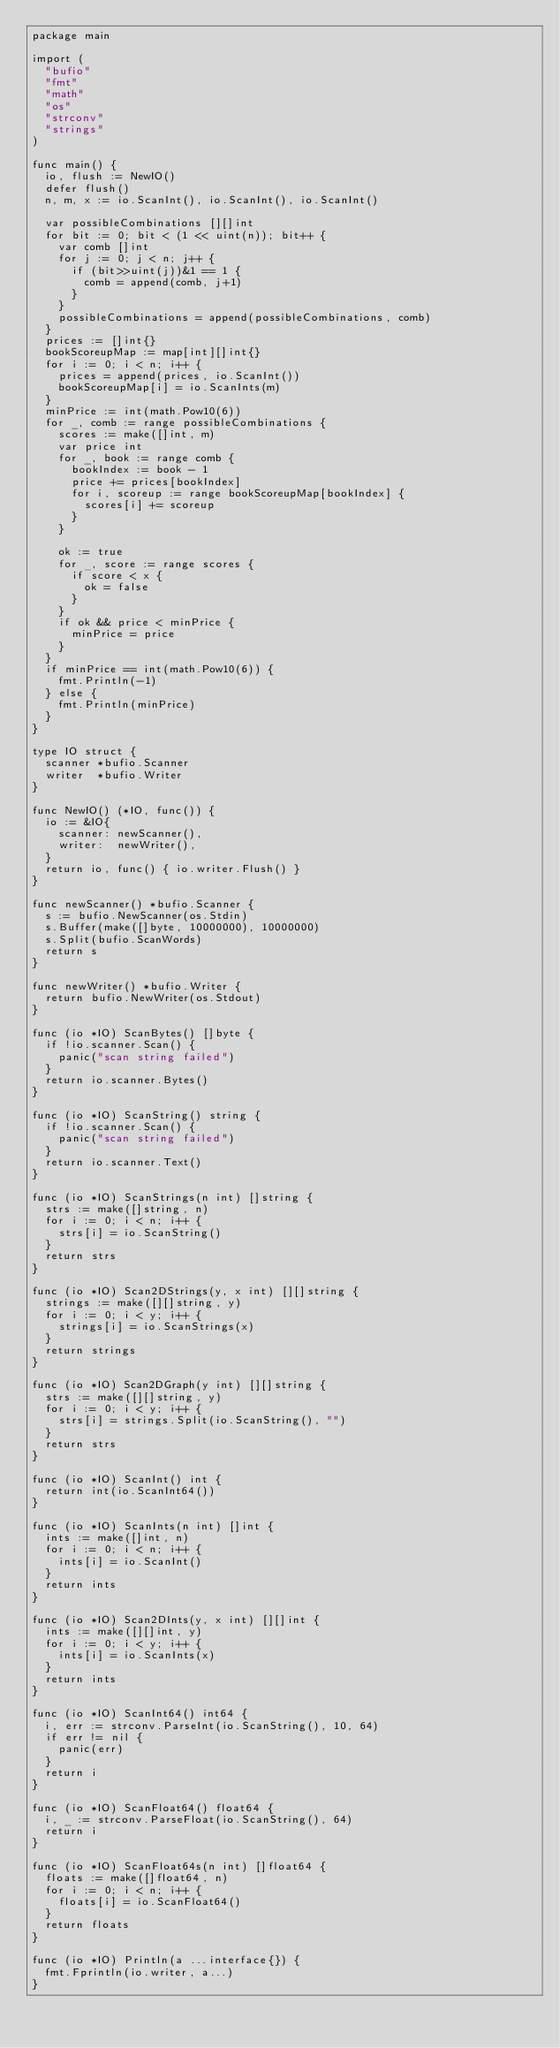<code> <loc_0><loc_0><loc_500><loc_500><_Go_>package main

import (
	"bufio"
	"fmt"
	"math"
	"os"
	"strconv"
	"strings"
)

func main() {
	io, flush := NewIO()
	defer flush()
	n, m, x := io.ScanInt(), io.ScanInt(), io.ScanInt()

	var possibleCombinations [][]int
	for bit := 0; bit < (1 << uint(n)); bit++ {
		var comb []int
		for j := 0; j < n; j++ {
			if (bit>>uint(j))&1 == 1 {
				comb = append(comb, j+1)
			}
		}
		possibleCombinations = append(possibleCombinations, comb)
	}
	prices := []int{}
	bookScoreupMap := map[int][]int{}
	for i := 0; i < n; i++ {
		prices = append(prices, io.ScanInt())
		bookScoreupMap[i] = io.ScanInts(m)
	}
	minPrice := int(math.Pow10(6))
	for _, comb := range possibleCombinations {
		scores := make([]int, m)
		var price int
		for _, book := range comb {
			bookIndex := book - 1
			price += prices[bookIndex]
			for i, scoreup := range bookScoreupMap[bookIndex] {
				scores[i] += scoreup
			}
		}

		ok := true
		for _, score := range scores {
			if score < x {
				ok = false
			}
		}
		if ok && price < minPrice {
			minPrice = price
		}
	}
	if minPrice == int(math.Pow10(6)) {
		fmt.Println(-1)
	} else {
		fmt.Println(minPrice)
	}
}

type IO struct {
	scanner *bufio.Scanner
	writer  *bufio.Writer
}

func NewIO() (*IO, func()) {
	io := &IO{
		scanner: newScanner(),
		writer:  newWriter(),
	}
	return io, func() { io.writer.Flush() }
}

func newScanner() *bufio.Scanner {
	s := bufio.NewScanner(os.Stdin)
	s.Buffer(make([]byte, 10000000), 10000000)
	s.Split(bufio.ScanWords)
	return s
}

func newWriter() *bufio.Writer {
	return bufio.NewWriter(os.Stdout)
}

func (io *IO) ScanBytes() []byte {
	if !io.scanner.Scan() {
		panic("scan string failed")
	}
	return io.scanner.Bytes()
}

func (io *IO) ScanString() string {
	if !io.scanner.Scan() {
		panic("scan string failed")
	}
	return io.scanner.Text()
}

func (io *IO) ScanStrings(n int) []string {
	strs := make([]string, n)
	for i := 0; i < n; i++ {
		strs[i] = io.ScanString()
	}
	return strs
}

func (io *IO) Scan2DStrings(y, x int) [][]string {
	strings := make([][]string, y)
	for i := 0; i < y; i++ {
		strings[i] = io.ScanStrings(x)
	}
	return strings
}

func (io *IO) Scan2DGraph(y int) [][]string {
	strs := make([][]string, y)
	for i := 0; i < y; i++ {
		strs[i] = strings.Split(io.ScanString(), "")
	}
	return strs
}

func (io *IO) ScanInt() int {
	return int(io.ScanInt64())
}

func (io *IO) ScanInts(n int) []int {
	ints := make([]int, n)
	for i := 0; i < n; i++ {
		ints[i] = io.ScanInt()
	}
	return ints
}

func (io *IO) Scan2DInts(y, x int) [][]int {
	ints := make([][]int, y)
	for i := 0; i < y; i++ {
		ints[i] = io.ScanInts(x)
	}
	return ints
}

func (io *IO) ScanInt64() int64 {
	i, err := strconv.ParseInt(io.ScanString(), 10, 64)
	if err != nil {
		panic(err)
	}
	return i
}

func (io *IO) ScanFloat64() float64 {
	i, _ := strconv.ParseFloat(io.ScanString(), 64)
	return i
}

func (io *IO) ScanFloat64s(n int) []float64 {
	floats := make([]float64, n)
	for i := 0; i < n; i++ {
		floats[i] = io.ScanFloat64()
	}
	return floats
}

func (io *IO) Println(a ...interface{}) {
	fmt.Fprintln(io.writer, a...)
}
</code> 